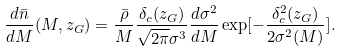Convert formula to latex. <formula><loc_0><loc_0><loc_500><loc_500>\frac { d \bar { n } } { d M } ( M , z _ { G } ) = \frac { \bar { \rho } } { M } \frac { \delta _ { c } ( z _ { G } ) } { \sqrt { 2 \pi } \sigma ^ { 3 } } \frac { d \sigma ^ { 2 } } { d M } \exp [ - \frac { \delta ^ { 2 } _ { c } ( z _ { G } ) } { 2 \sigma ^ { 2 } ( M ) } ] .</formula> 